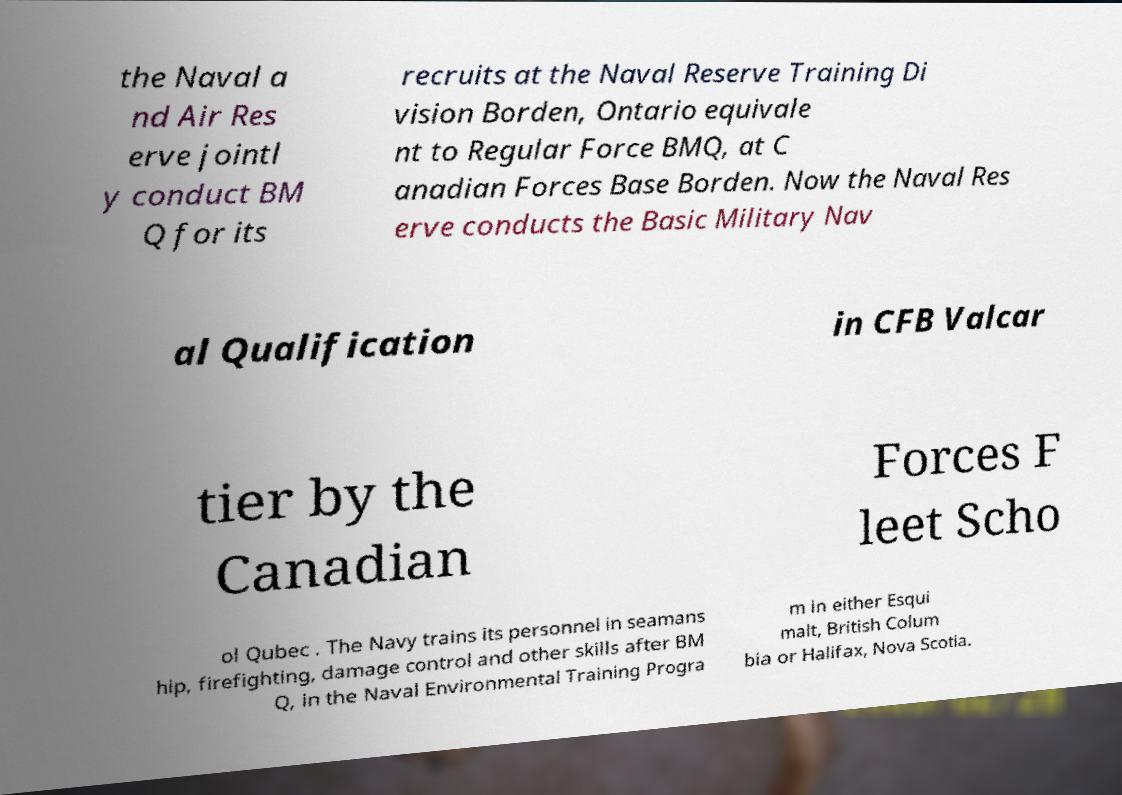I need the written content from this picture converted into text. Can you do that? the Naval a nd Air Res erve jointl y conduct BM Q for its recruits at the Naval Reserve Training Di vision Borden, Ontario equivale nt to Regular Force BMQ, at C anadian Forces Base Borden. Now the Naval Res erve conducts the Basic Military Nav al Qualification in CFB Valcar tier by the Canadian Forces F leet Scho ol Qubec . The Navy trains its personnel in seamans hip, firefighting, damage control and other skills after BM Q, in the Naval Environmental Training Progra m in either Esqui malt, British Colum bia or Halifax, Nova Scotia. 